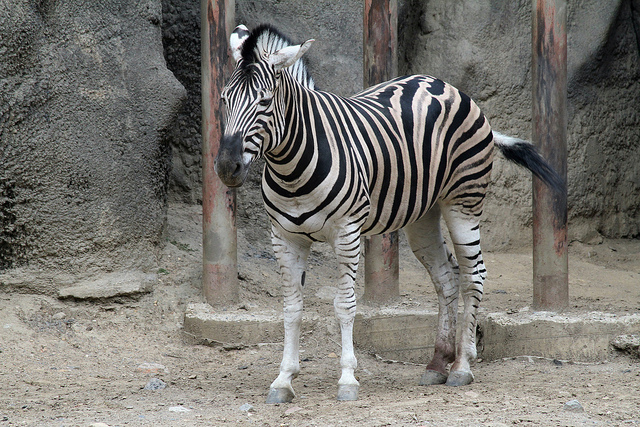<image>Is this zebra in a zoo? It is unknown whether this zebra is in a zoo. Is this zebra in a zoo? I am not sure if this zebra is in a zoo. It can be in a zoo or it can be somewhere else. 